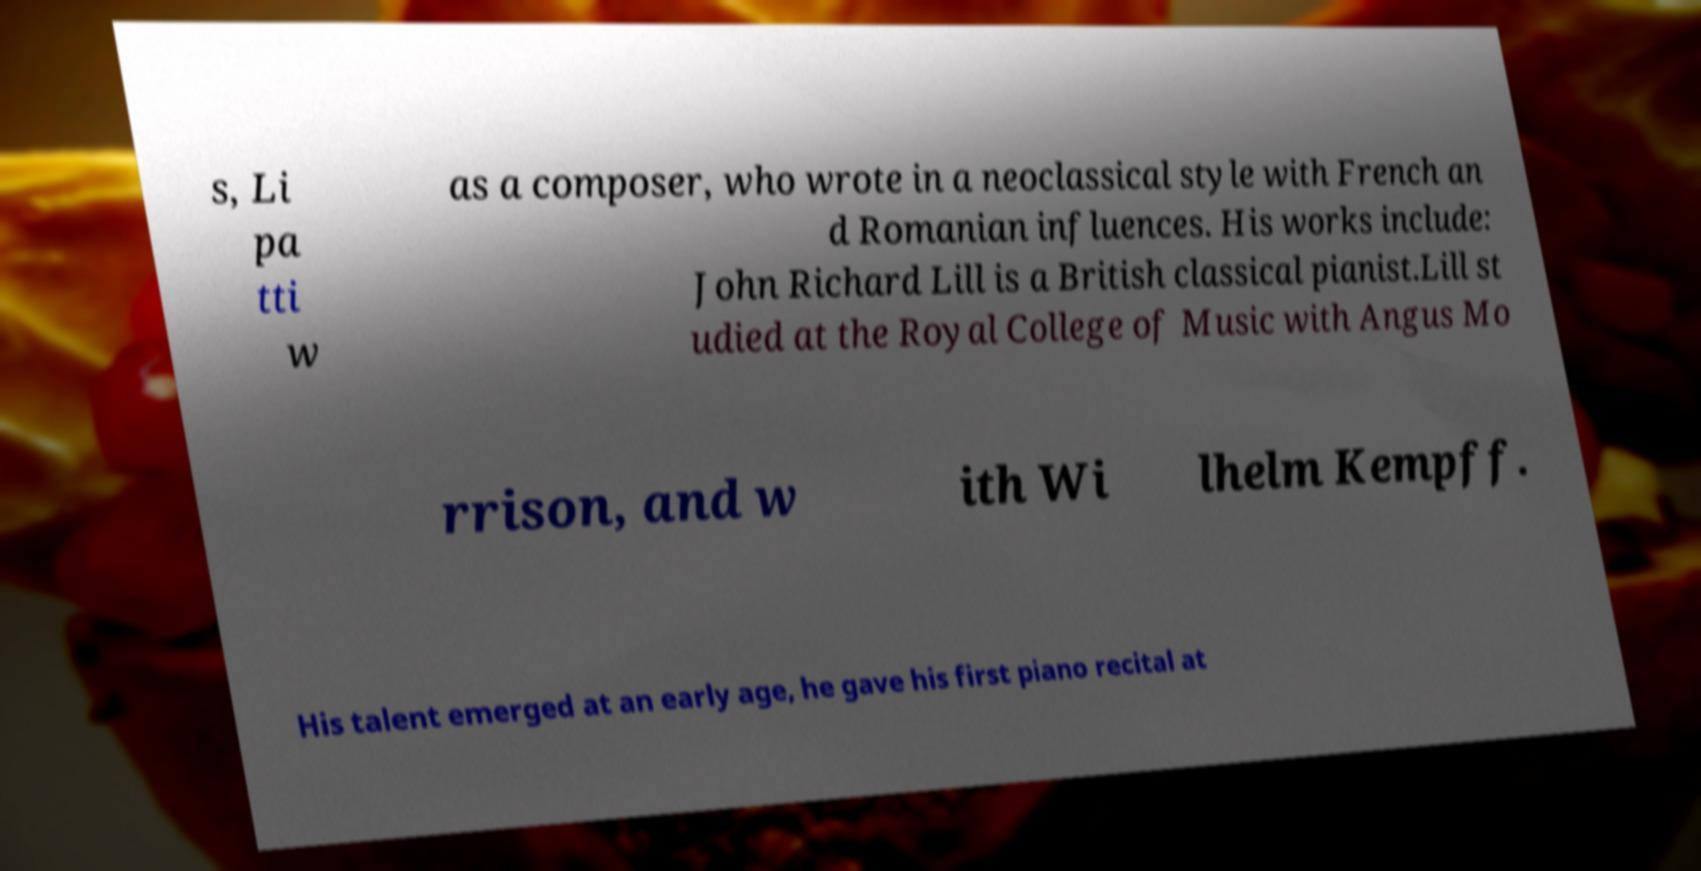I need the written content from this picture converted into text. Can you do that? s, Li pa tti w as a composer, who wrote in a neoclassical style with French an d Romanian influences. His works include: John Richard Lill is a British classical pianist.Lill st udied at the Royal College of Music with Angus Mo rrison, and w ith Wi lhelm Kempff. His talent emerged at an early age, he gave his first piano recital at 